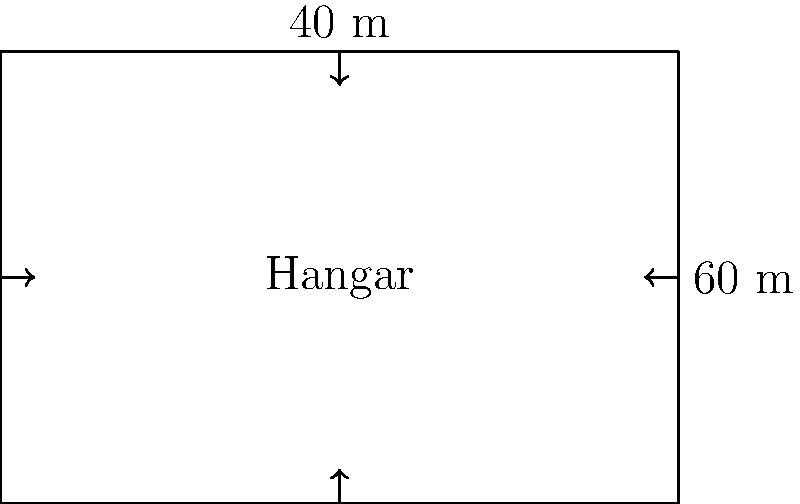A new rectangular hangar is being constructed at your airport to accommodate both fixed-wing aircraft and helicopters. The hangar measures 60 meters in length and 40 meters in width. What is the total floor area of the hangar in square meters? To calculate the area of a rectangular hangar, we need to multiply its length by its width. Let's break it down step-by-step:

1. Identify the given dimensions:
   - Length (l) = 60 meters
   - Width (w) = 40 meters

2. Use the formula for the area of a rectangle:
   Area (A) = length (l) × width (w)

3. Substitute the values into the formula:
   A = 60 m × 40 m

4. Perform the multiplication:
   A = 2400 m²

Therefore, the total floor area of the hangar is 2400 square meters.
Answer: 2400 m² 